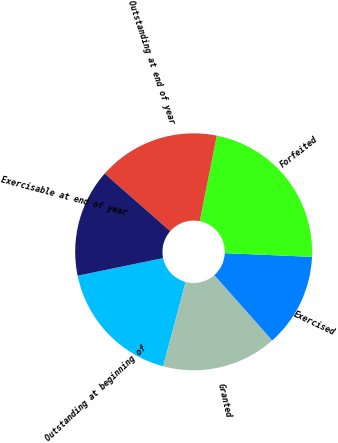<chart> <loc_0><loc_0><loc_500><loc_500><pie_chart><fcel>Outstanding at beginning of<fcel>Granted<fcel>Exercised<fcel>Forfeited<fcel>Outstanding at end of year<fcel>Exercisable at end of year<nl><fcel>17.63%<fcel>15.68%<fcel>12.77%<fcel>22.55%<fcel>16.65%<fcel>14.71%<nl></chart> 